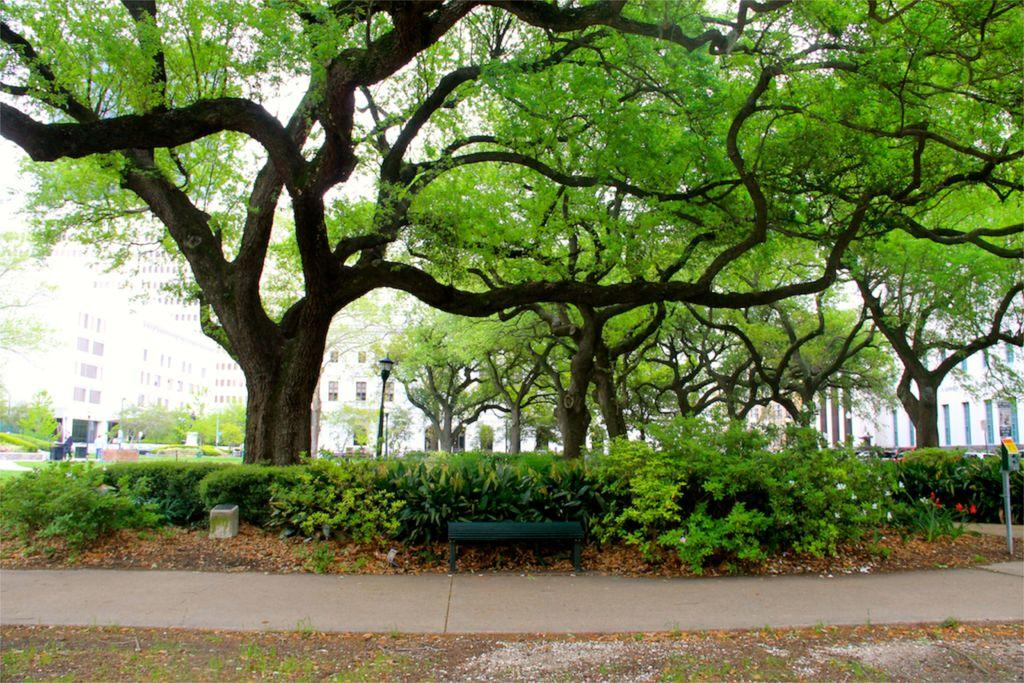What type of seating is present in the image? There is a wooden bench in the image. What type of vegetation can be seen in the image? There are plants and trees in the image. What structure is visible in the image? There is a pole in the image. What can be seen in the background of the image? In the background, there are buildings, windows, trees, and light poles. What else is visible in the background of the image? There are other unspecified items in the background. What part of the natural environment is visible in the image? The sky is visible in the background. What type of company is represented by the chicken in the image? There is no chicken present in the image. How does the shake affect the wooden bench in the image? There is no shake present in the image, so it cannot affect the wooden bench. 